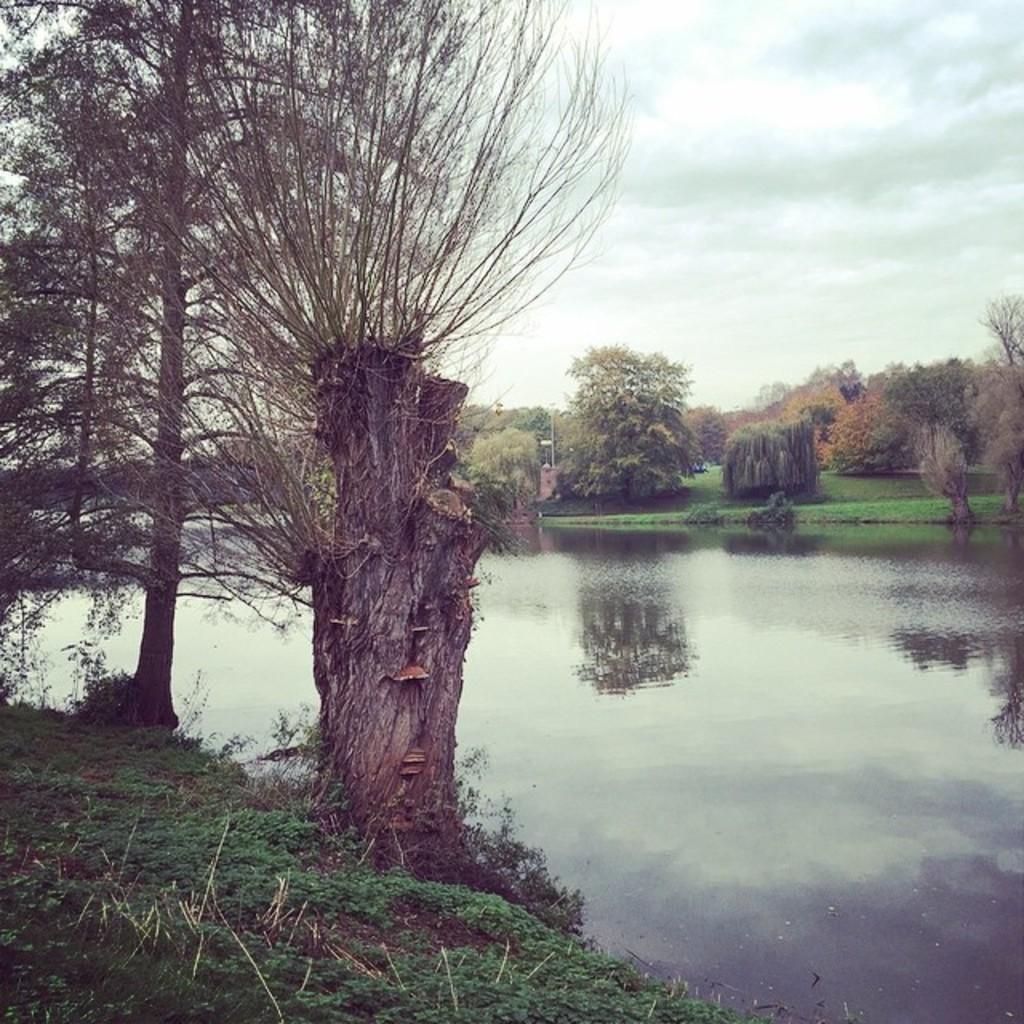Could you give a brief overview of what you see in this image? This image is taken outdoors. At the top of the image there is the sky with clouds. At the bottom of the image there is a ground with grass on it. On the right side of the image there is a river with water. In the background there are many trees and plants on the ground. 